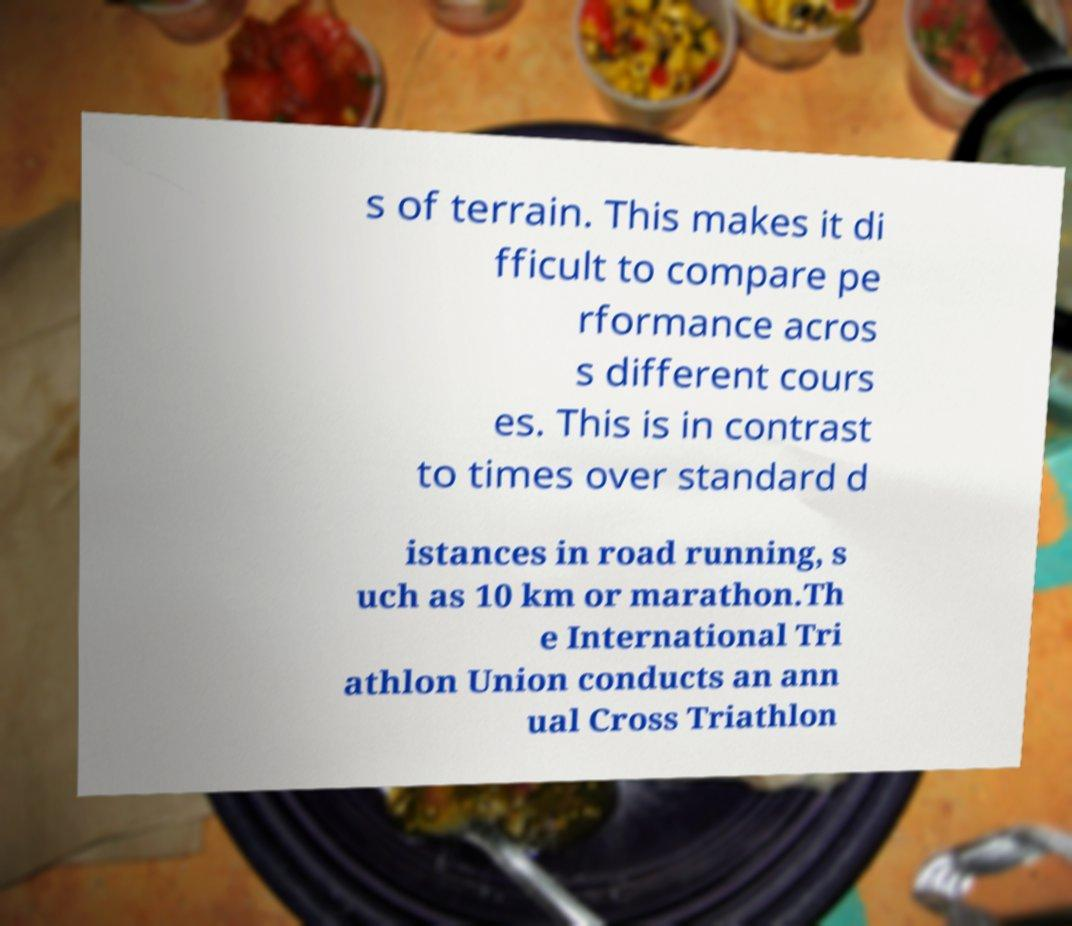There's text embedded in this image that I need extracted. Can you transcribe it verbatim? s of terrain. This makes it di fficult to compare pe rformance acros s different cours es. This is in contrast to times over standard d istances in road running, s uch as 10 km or marathon.Th e International Tri athlon Union conducts an ann ual Cross Triathlon 